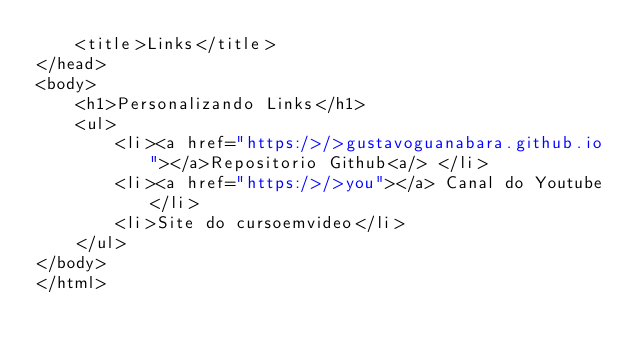Convert code to text. <code><loc_0><loc_0><loc_500><loc_500><_HTML_>    <title>Links</title>
</head>
<body>
    <h1>Personalizando Links</h1>
    <ul>
        <li><a href="https:/>/>gustavoguanabara.github.io"></a>Repositorio Github<a/> </li>
        <li><a href="https:/>/>you"></a> Canal do Youtube</li>
        <li>Site do cursoemvideo</li>
    </ul>
</body>
</html></code> 